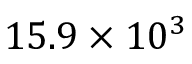<formula> <loc_0><loc_0><loc_500><loc_500>1 5 . 9 \times 1 0 ^ { 3 }</formula> 